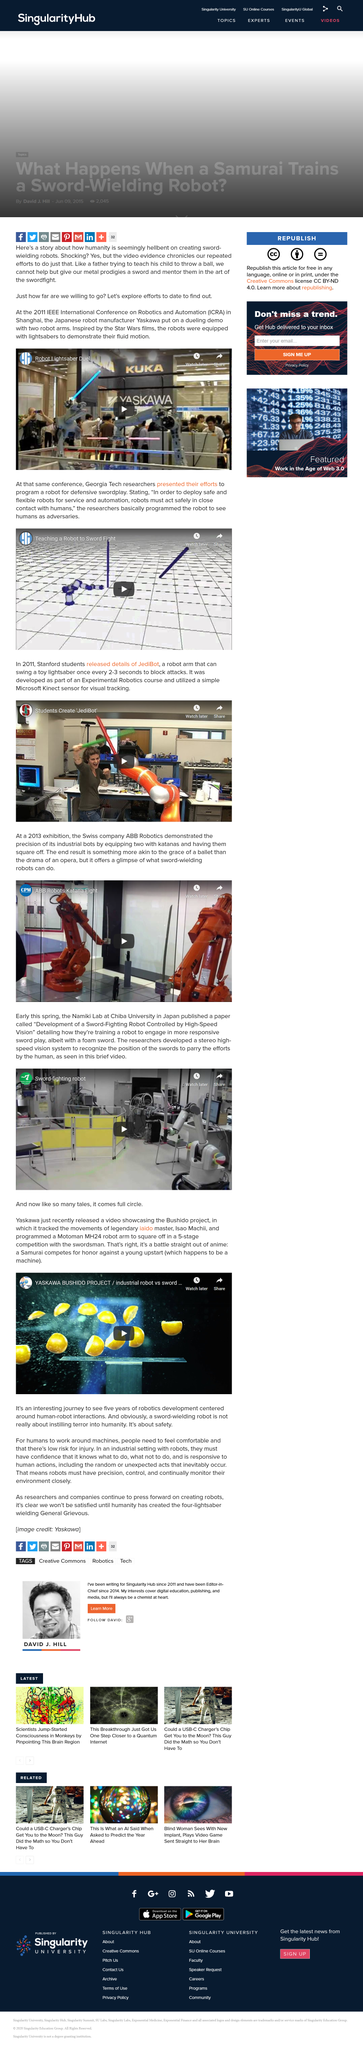Outline some significant characteristics in this image. The demo was filmed in the year 2011. Yaskawa demonstrated duelling robots at the 2011 IEEE International Conference on Robotics and Automations. The inspiration for the film was Star Wars. 